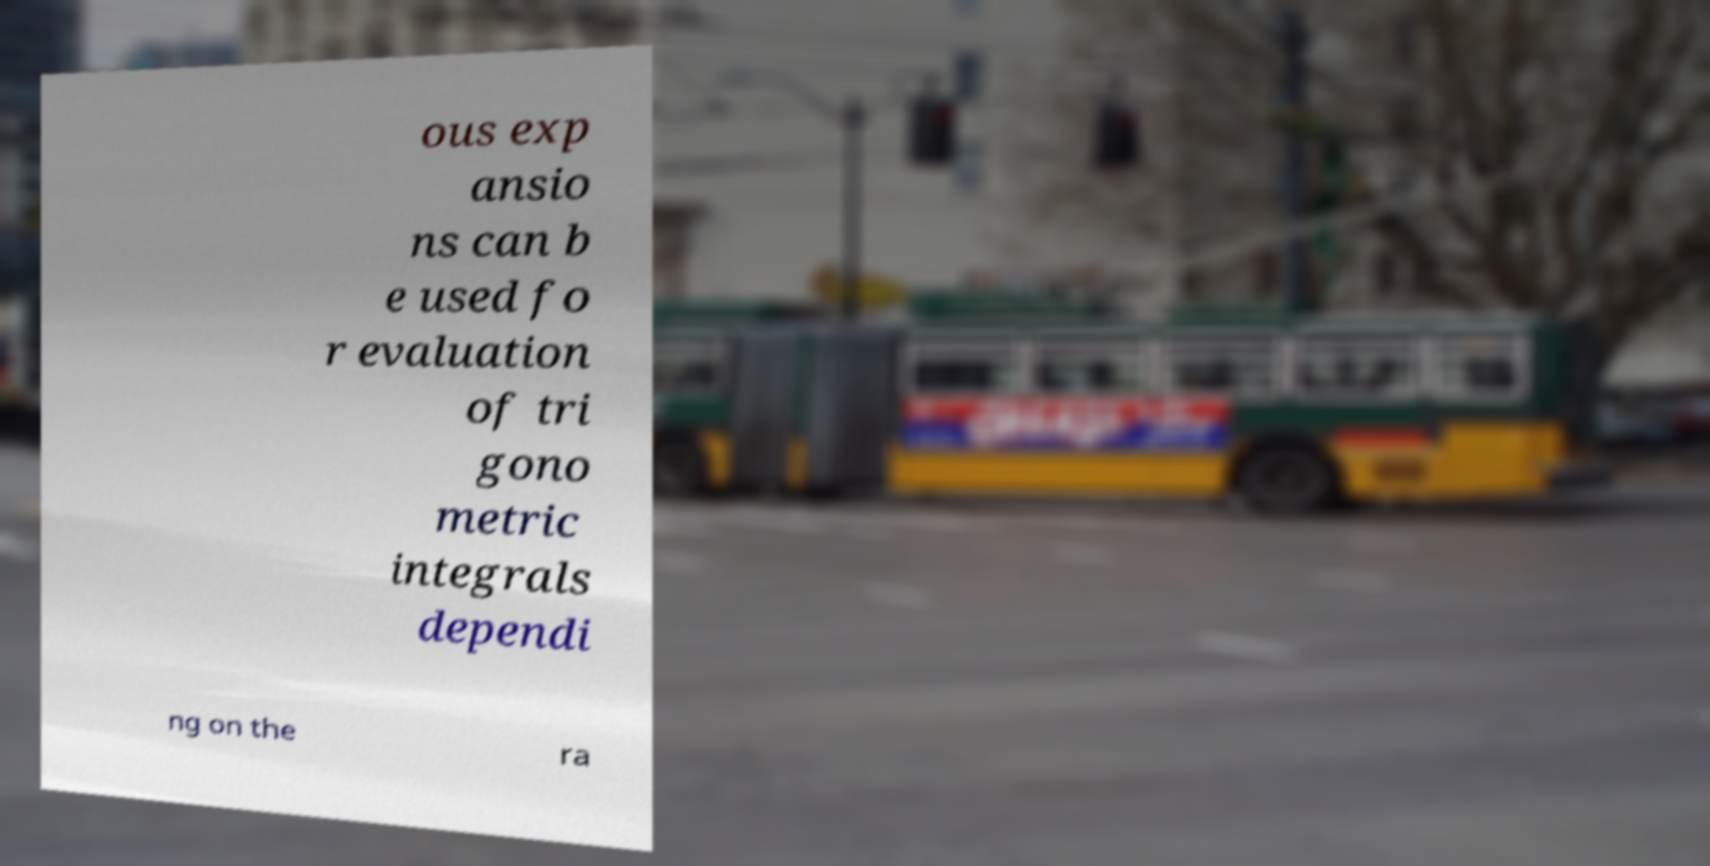For documentation purposes, I need the text within this image transcribed. Could you provide that? ous exp ansio ns can b e used fo r evaluation of tri gono metric integrals dependi ng on the ra 